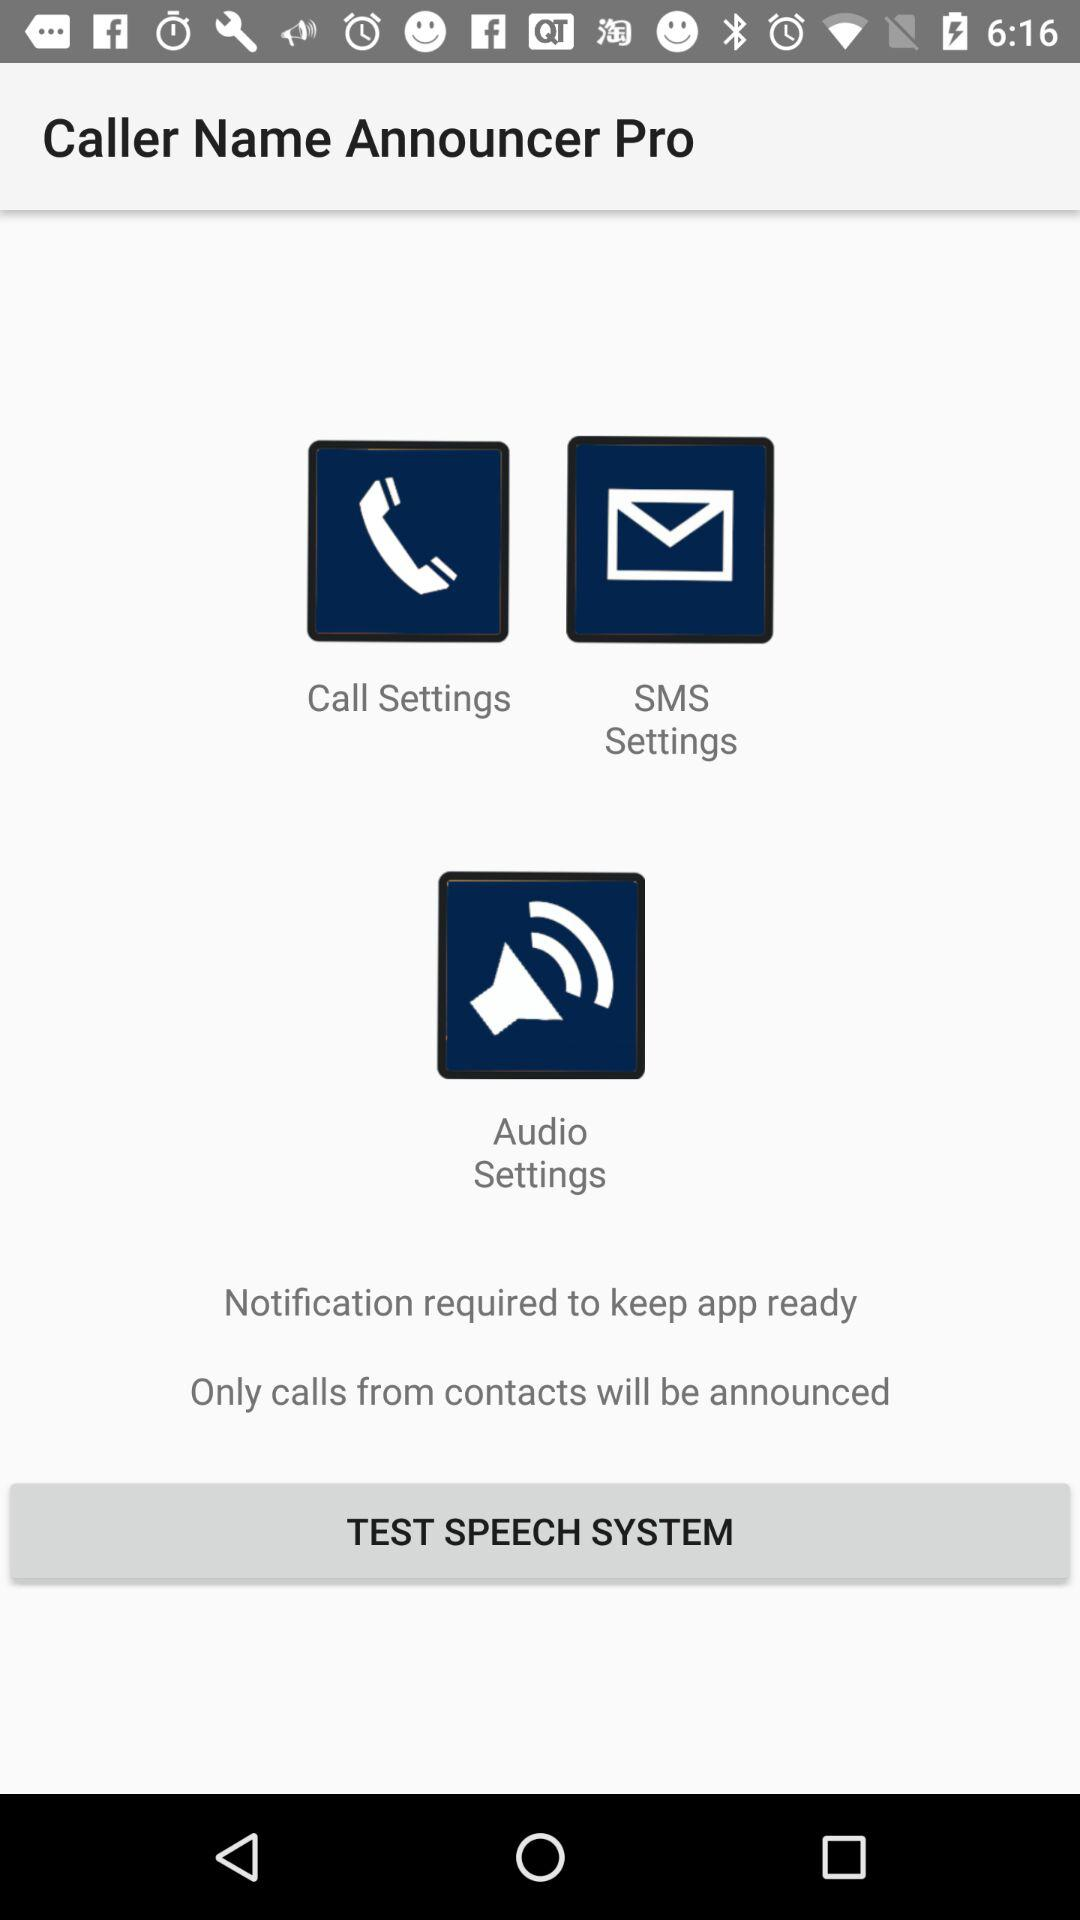What is the application name? The application name is "Caller Name Announcer Pro". 